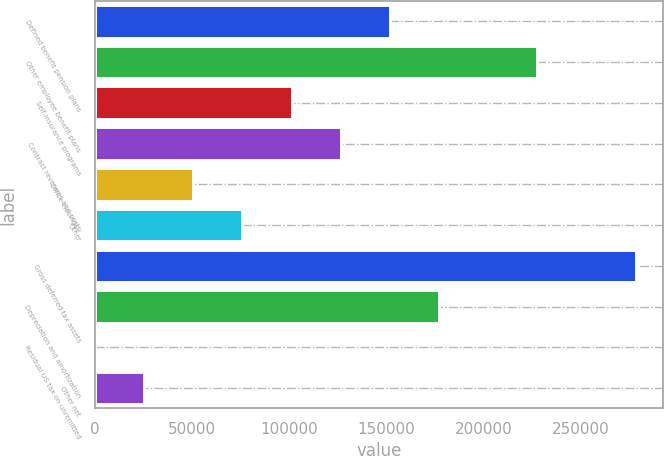Convert chart to OTSL. <chart><loc_0><loc_0><loc_500><loc_500><bar_chart><fcel>Defined benefit pension plans<fcel>Other employee benefit plans<fcel>Self-insurance programs<fcel>Contract revenues and costs<fcel>Office closings /<fcel>Other<fcel>Gross deferred tax assets<fcel>Depreciation and amortization<fcel>Residual US tax on unremitted<fcel>Other net<nl><fcel>151957<fcel>227852<fcel>101360<fcel>126658<fcel>50763.6<fcel>76061.9<fcel>278448<fcel>177255<fcel>167<fcel>25465.3<nl></chart> 